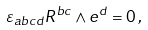Convert formula to latex. <formula><loc_0><loc_0><loc_500><loc_500>\varepsilon _ { a b c d } R ^ { b c } \wedge e ^ { d } = 0 \, ,</formula> 